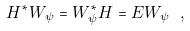Convert formula to latex. <formula><loc_0><loc_0><loc_500><loc_500>H ^ { * } W _ { \psi } = W _ { \psi } ^ { * } H = E W _ { \psi } \ ,</formula> 